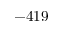Convert formula to latex. <formula><loc_0><loc_0><loc_500><loc_500>- 4 1 9</formula> 